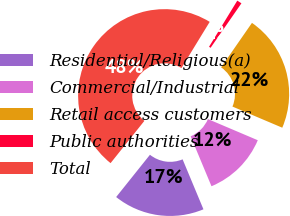<chart> <loc_0><loc_0><loc_500><loc_500><pie_chart><fcel>Residential/Religious(a)<fcel>Commercial/Industrial<fcel>Retail access customers<fcel>Public authorities<fcel>Total<nl><fcel>17.03%<fcel>12.32%<fcel>21.74%<fcel>0.91%<fcel>48.01%<nl></chart> 